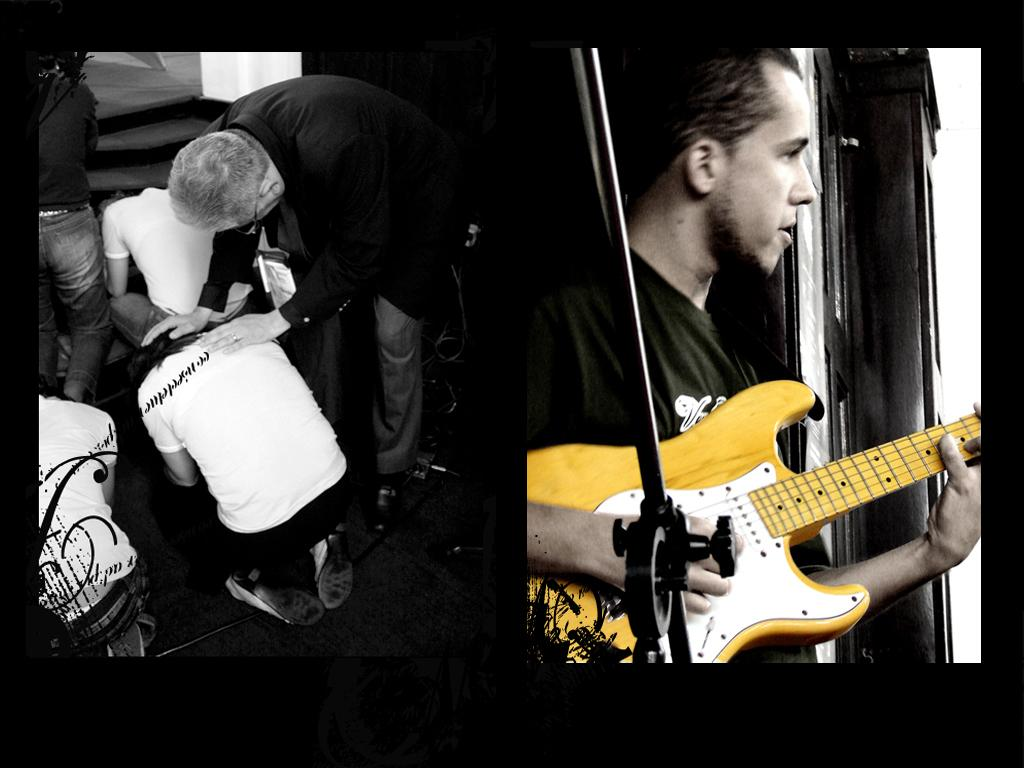Who is the main subject in the image? There is a boy in the image. What is the boy doing in the image? The boy is playing a yellow guitar. How many boys are lying down in the image? There are two boys lying down in the image. What is the man wearing in the image? The man is wearing a black coat. What is the man doing with the two boys in the image? The man is keeping his hand on the heads of the two boys. What type of cheese is being served in the image? There is no cheese present in the image. What kind of vessel is being used by the boys in the image? There is no vessel present in the image. 